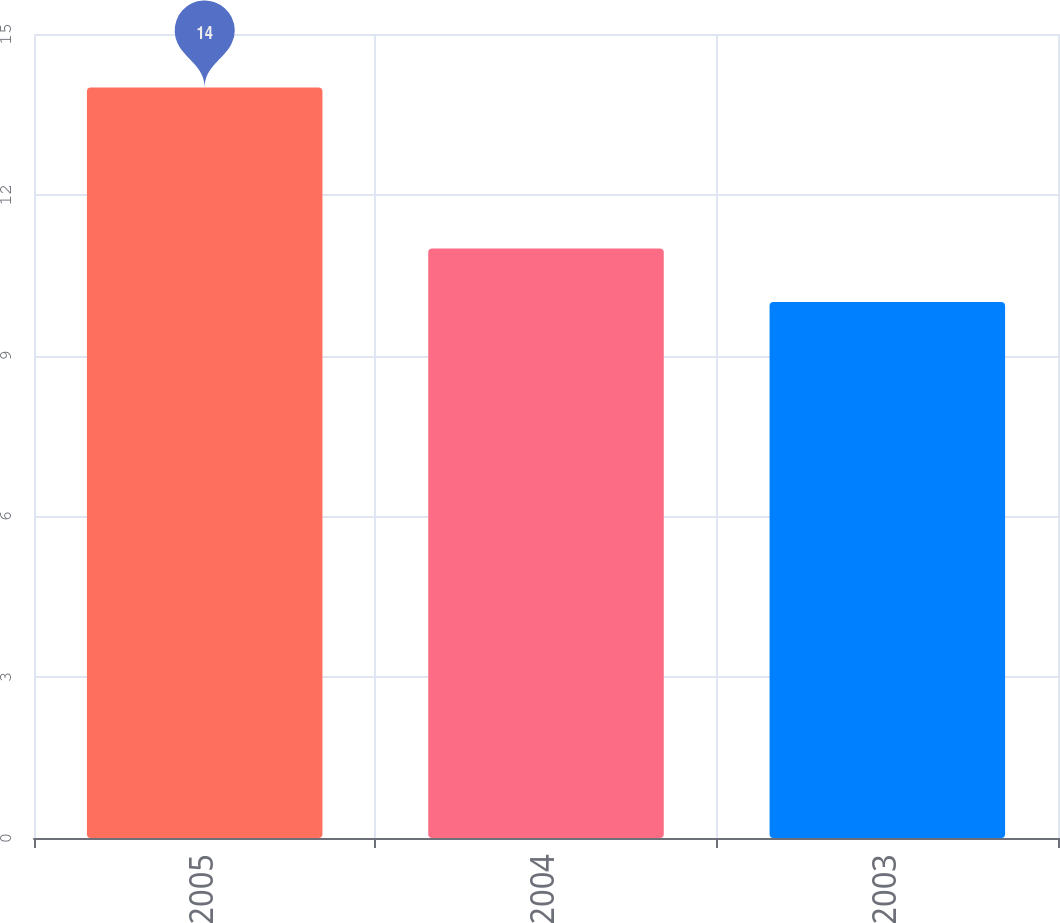<chart> <loc_0><loc_0><loc_500><loc_500><bar_chart><fcel>2005<fcel>2004<fcel>2003<nl><fcel>14<fcel>11<fcel>10<nl></chart> 